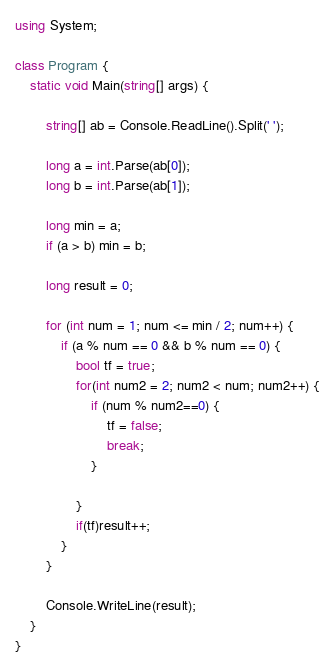Convert code to text. <code><loc_0><loc_0><loc_500><loc_500><_C#_>using System;

class Program {
    static void Main(string[] args) {

        string[] ab = Console.ReadLine().Split(' ');

        long a = int.Parse(ab[0]);
        long b = int.Parse(ab[1]);

        long min = a;
        if (a > b) min = b;

        long result = 0;

        for (int num = 1; num <= min / 2; num++) {
            if (a % num == 0 && b % num == 0) {
                bool tf = true;
                for(int num2 = 2; num2 < num; num2++) {
                    if (num % num2==0) {
                        tf = false;
                        break;
                    }

                }
                if(tf)result++;
            }
        }

        Console.WriteLine(result);
    }
}

</code> 